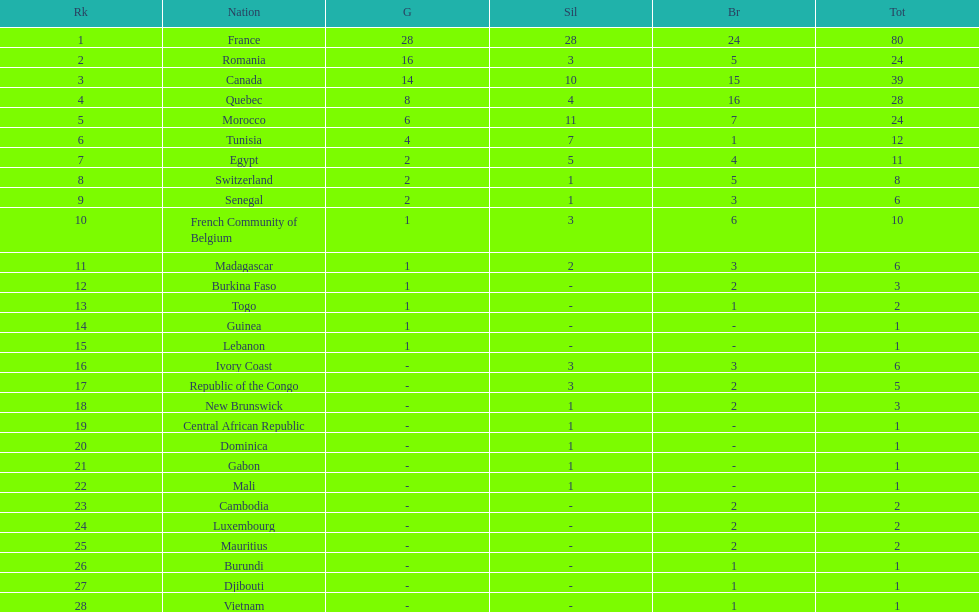What was the total medal count of switzerland? 8. 